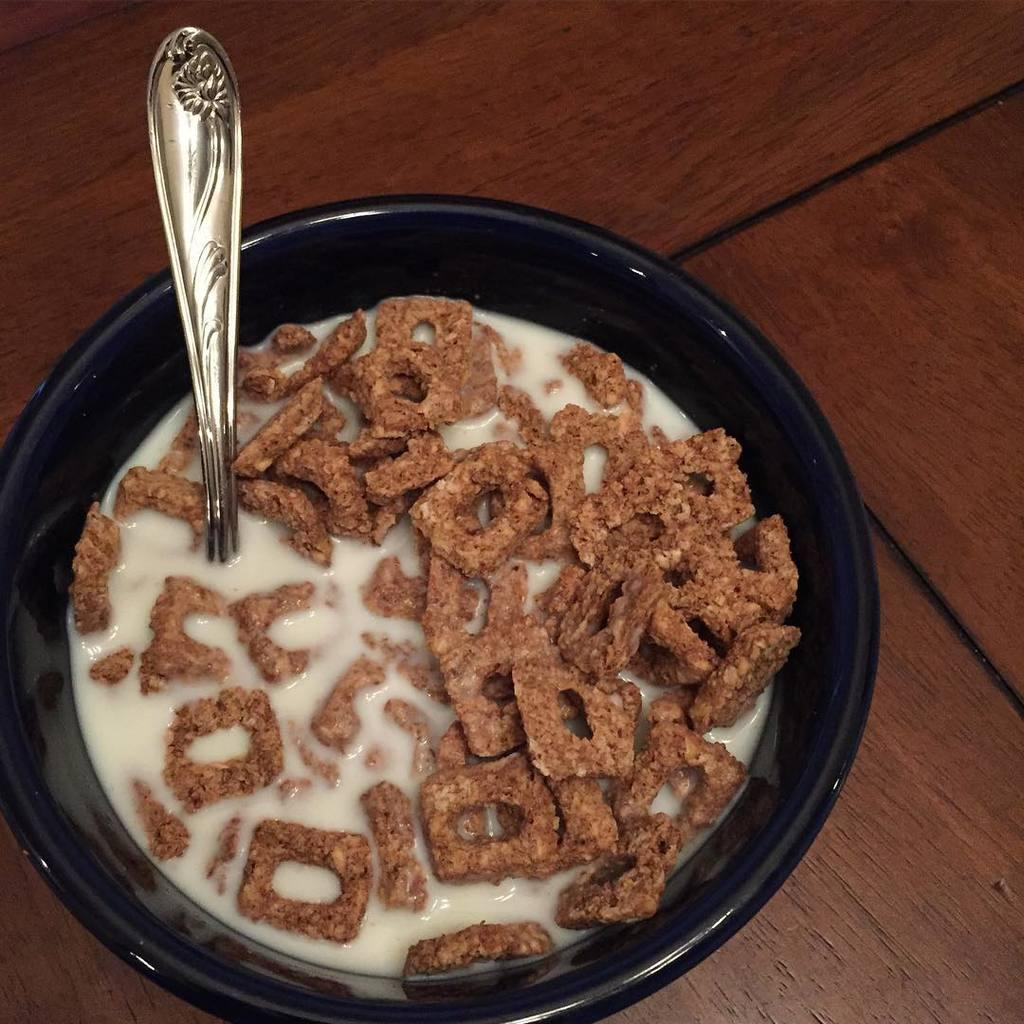What is the main subject of the image? The main subject of the image is a bowl. What is inside the bowl? There is a food item in the bowl. What utensil is present in the image? A spoon is present in the image. What type of net can be seen in the image? There is no net present in the image. 